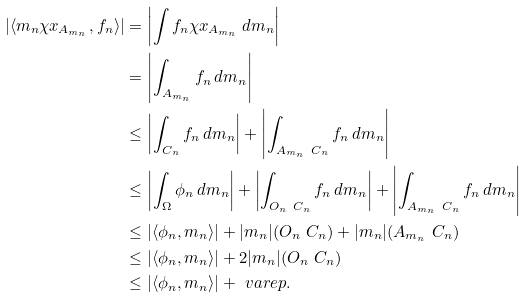Convert formula to latex. <formula><loc_0><loc_0><loc_500><loc_500>| \langle m _ { n } \chi x _ { A _ { m _ { n } } } , f _ { n } \rangle | & = \left | \int f _ { n } \chi x _ { A _ { m _ { n } } } \, d m _ { n } \right | \\ & = \left | \int _ { A _ { m _ { n } } } f _ { n } \, d m _ { n } \right | \\ & \leq \left | \int _ { C _ { n } } f _ { n } \, d m _ { n } \right | + \left | \int _ { A _ { m _ { n } } \ C _ { n } } f _ { n } \, d m _ { n } \right | \\ & \leq \left | \int _ { \Omega } \phi _ { n } \, d m _ { n } \right | + \left | \int _ { O _ { n } \ C _ { n } } f _ { n } \, d m _ { n } \right | + \left | \int _ { A _ { m _ { n } } \ C _ { n } } f _ { n } \, d m _ { n } \right | \\ & \leq | \langle \phi _ { n } , m _ { n } \rangle | + | m _ { n } | ( O _ { n } \ C _ { n } ) + | m _ { n } | ( A _ { m _ { n } } \ C _ { n } ) \\ & \leq | \langle \phi _ { n } , m _ { n } \rangle | + 2 | m _ { n } | ( O _ { n } \ C _ { n } ) \\ & \leq | \langle \phi _ { n } , m _ { n } \rangle | + \ v a r e p .</formula> 